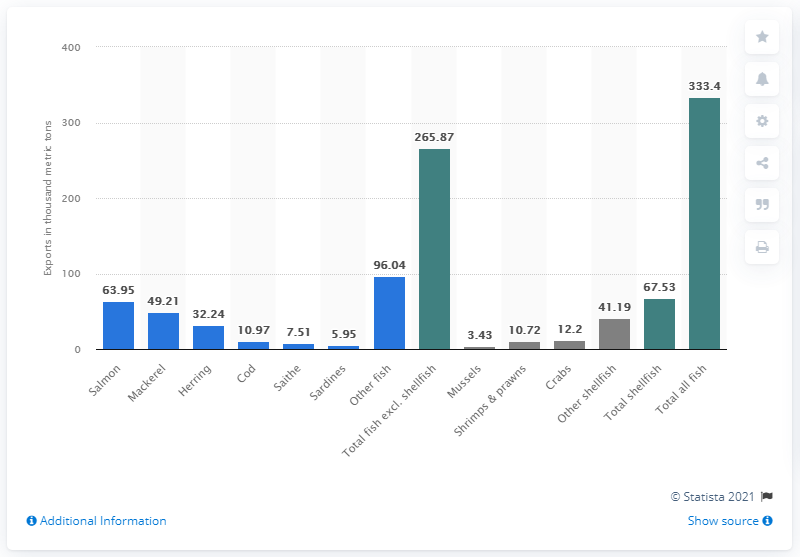Identify some key points in this picture. The leading fish type that the UK exported to the EU28 countries in 2019 was salmon. 